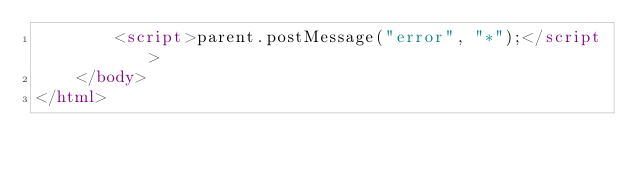Convert code to text. <code><loc_0><loc_0><loc_500><loc_500><_HTML_>        <script>parent.postMessage("error", "*");</script>
    </body>
</html></code> 